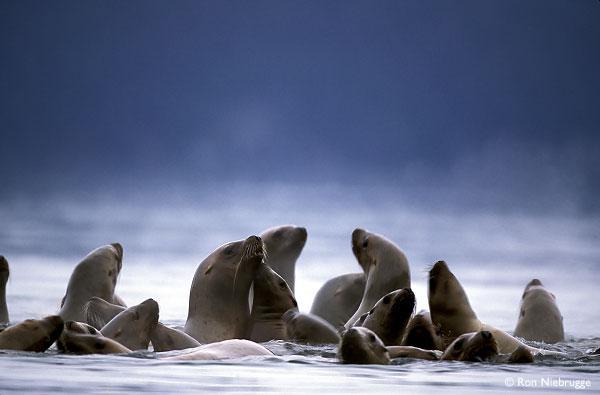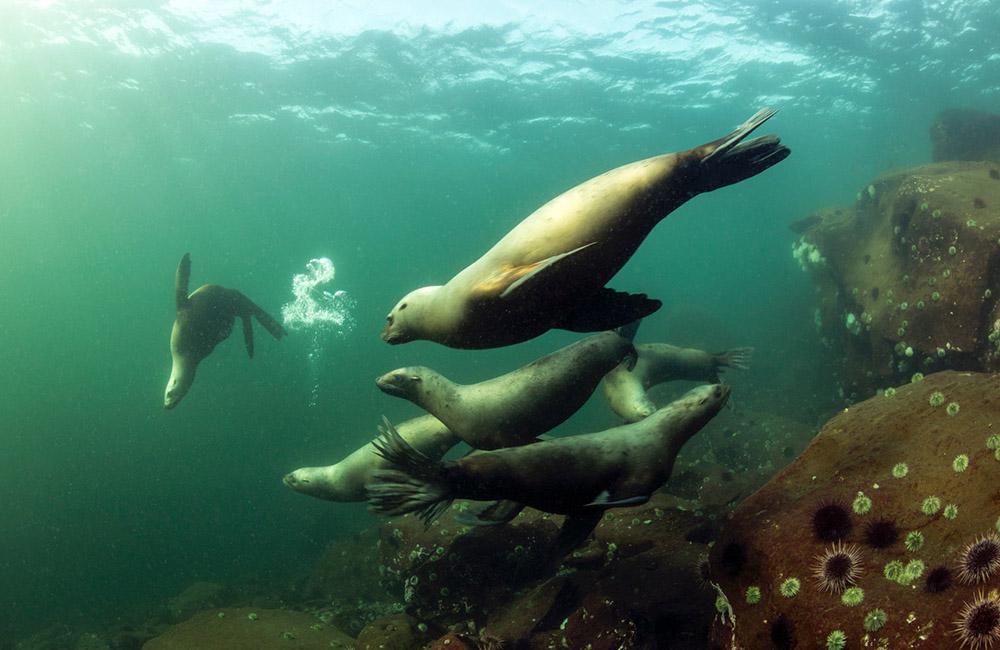The first image is the image on the left, the second image is the image on the right. Analyze the images presented: Is the assertion "There are more than ten sea lions in the images." valid? Answer yes or no. Yes. The first image is the image on the left, the second image is the image on the right. Examine the images to the left and right. Is the description "The right image image contains exactly one seal." accurate? Answer yes or no. No. 